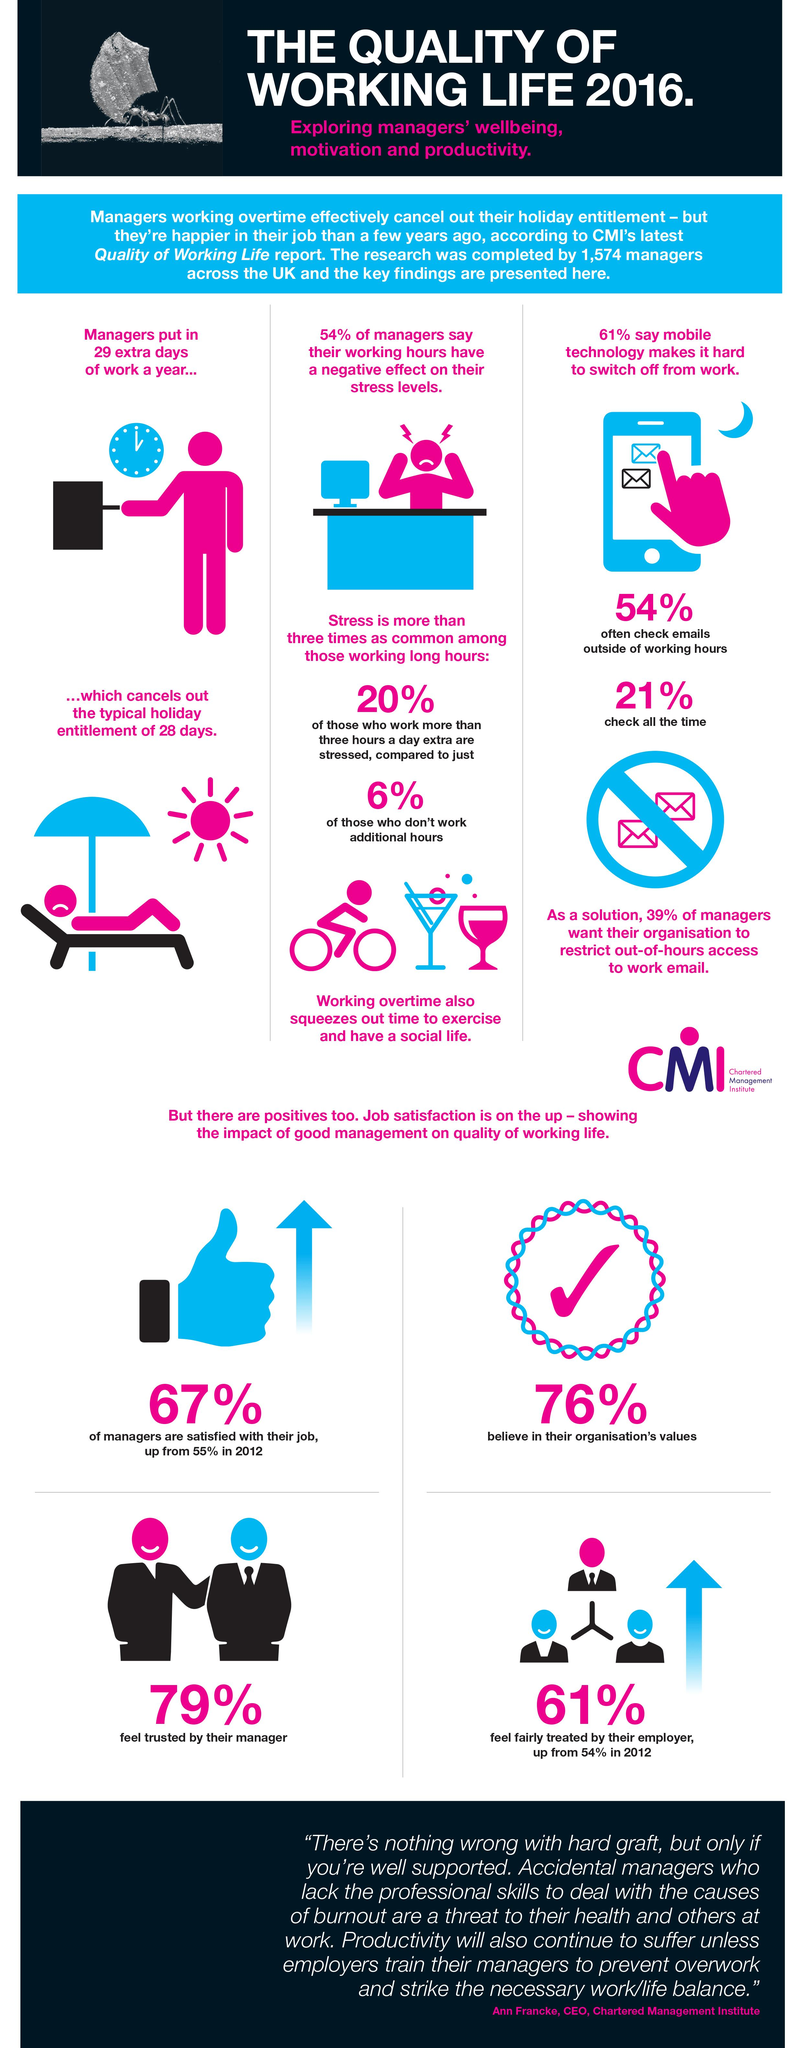Draw attention to some important aspects in this diagram. According to a recent survey, 21% of managers consistently check their emails on their phone all the time. Sixty-one percent of employees feel trusted by their employer. According to a recent survey, 24% of managers do not believe in their organization's values. A significant percentage of managers, 54%, believe that working hours contribute to their stress levels, indicating that working hours may be a significant factor in stress levels for many managers. 